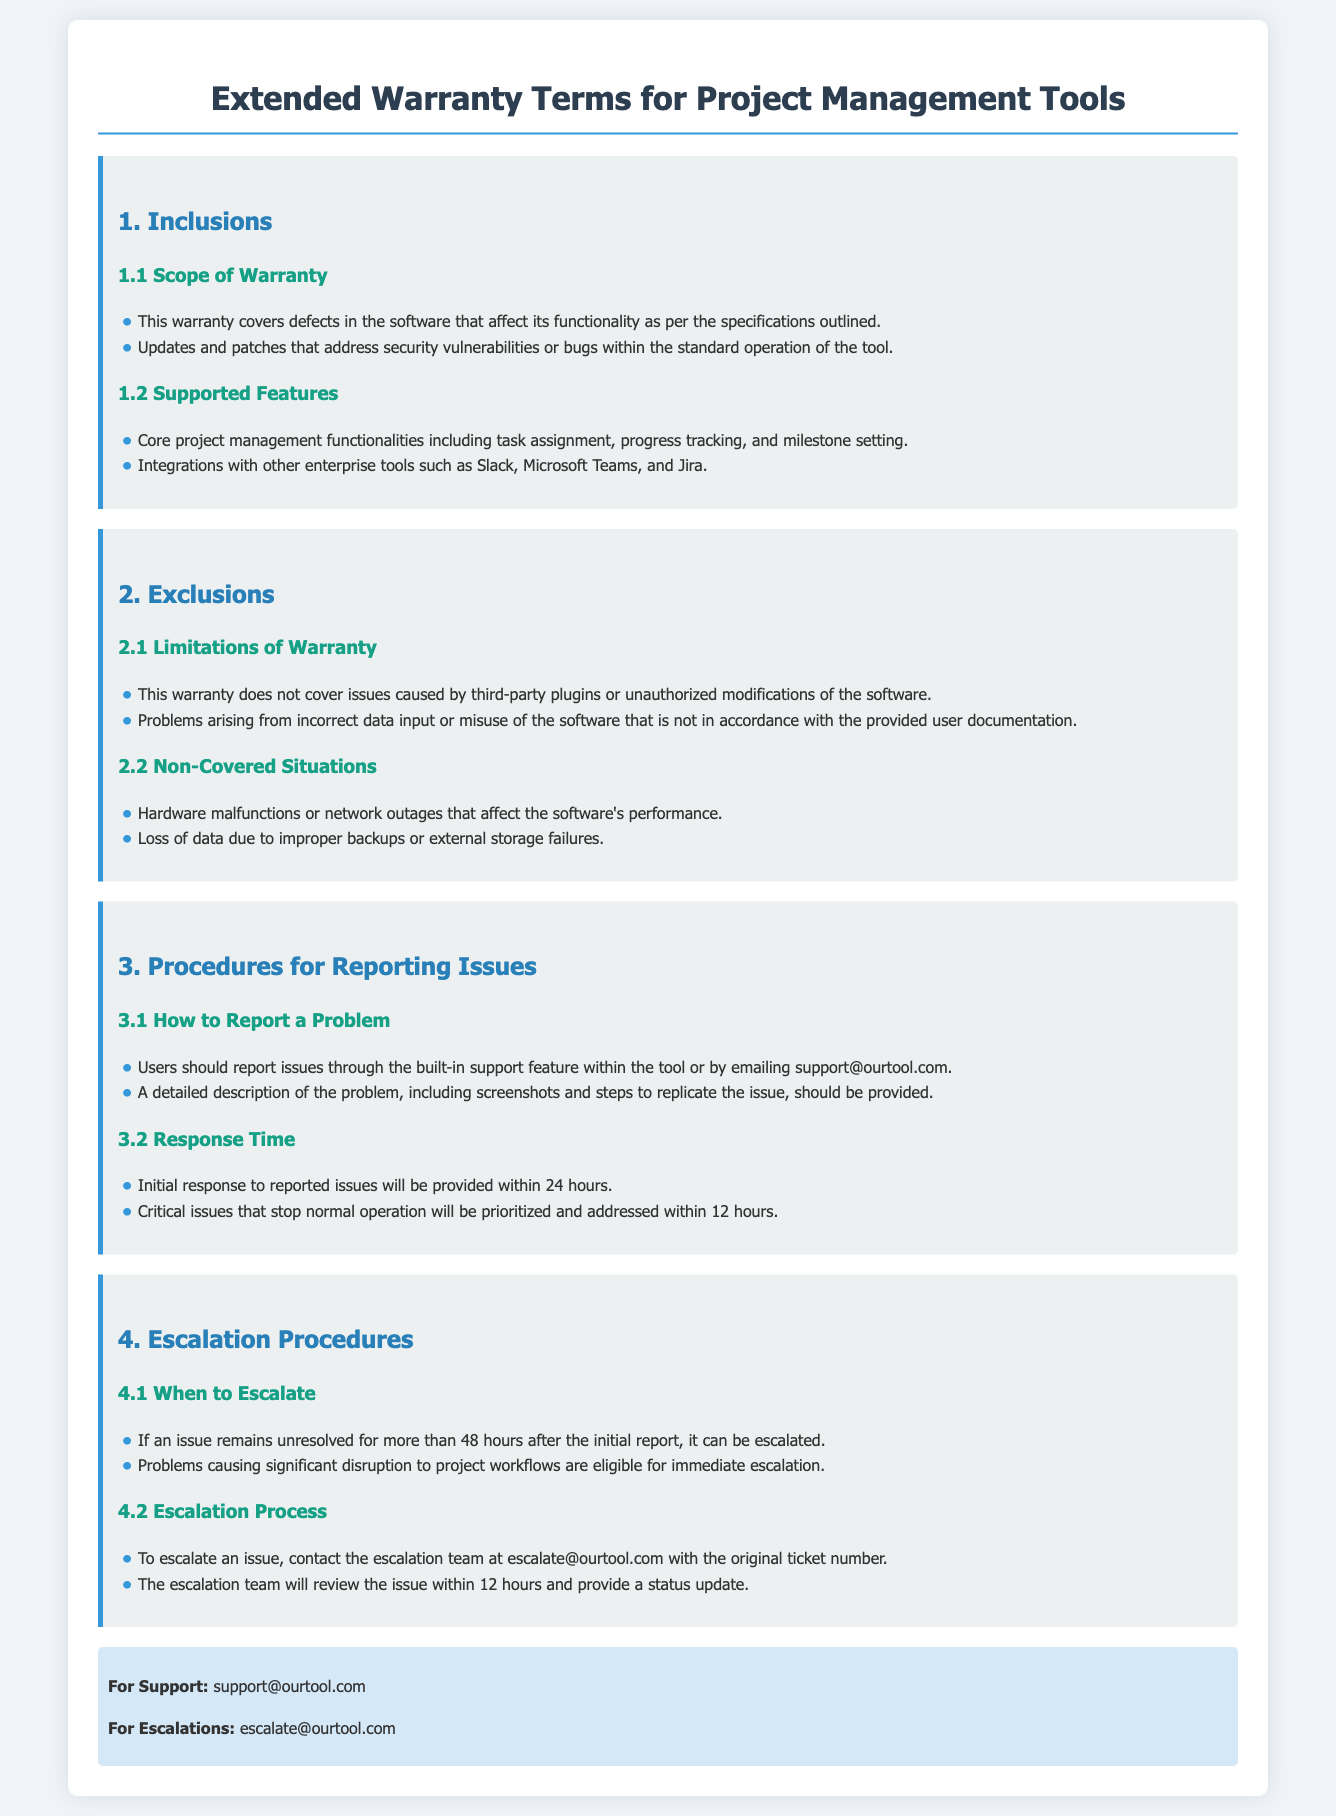What is covered under the warranty? The warranty covers defects in the software that affect functionality and updates/patches for security vulnerabilities or bugs.
Answer: Defects in the software and updates/patches What should users provide when reporting a problem? Users should provide a detailed description of the problem, including screenshots and steps to replicate the issue.
Answer: A detailed description, screenshots, and steps to replicate How long will it take to receive a response for a critical issue? Critical issues that stop normal operation will be prioritized and addressed within a specific time frame.
Answer: 12 hours What is the report email for support? The document provides a specific email address for support inquiries.
Answer: support@ourtool.com How long must an issue remain unresolved before it can be escalated? There is a specified time frame for escalation regarding unresolved issues.
Answer: 48 hours What actions cause the warranty to be void? Specific actions related to third-party plugins and unauthorized modifications are mentioned as exclusions to the warranty.
Answer: Third-party plugins or unauthorized modifications When will the escalation team review an escalated issue? The document states the timeframe for the escalation team to review escalated issues.
Answer: 12 hours What types of software situations are not covered by this warranty? Certain software malfunctions, data losses, and specific misuse scenarios are outlined as exclusions.
Answer: Hardware malfunctions or network outages 